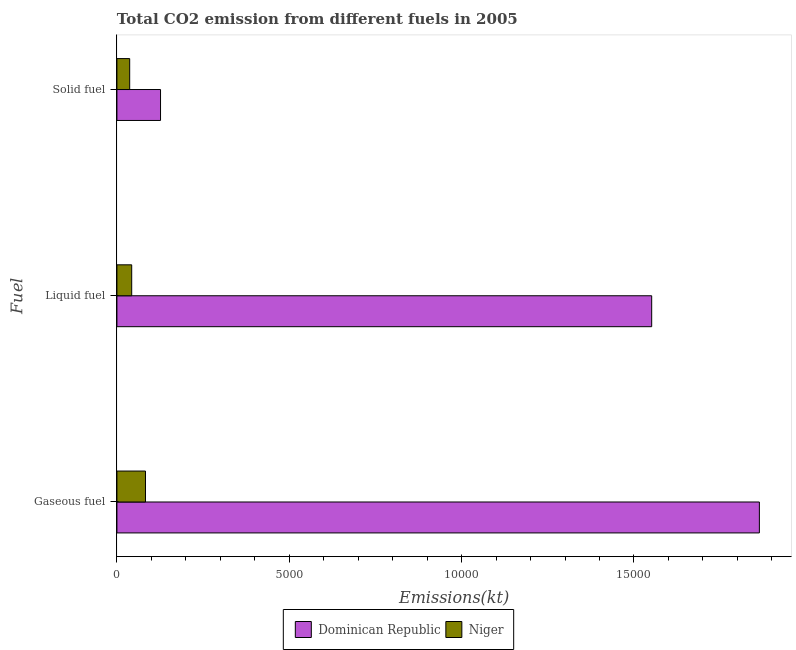How many groups of bars are there?
Make the answer very short. 3. How many bars are there on the 1st tick from the top?
Offer a terse response. 2. What is the label of the 2nd group of bars from the top?
Provide a short and direct response. Liquid fuel. What is the amount of co2 emissions from solid fuel in Dominican Republic?
Give a very brief answer. 1265.12. Across all countries, what is the maximum amount of co2 emissions from gaseous fuel?
Your answer should be compact. 1.86e+04. Across all countries, what is the minimum amount of co2 emissions from liquid fuel?
Give a very brief answer. 429.04. In which country was the amount of co2 emissions from gaseous fuel maximum?
Offer a terse response. Dominican Republic. In which country was the amount of co2 emissions from liquid fuel minimum?
Offer a very short reply. Niger. What is the total amount of co2 emissions from gaseous fuel in the graph?
Provide a short and direct response. 1.95e+04. What is the difference between the amount of co2 emissions from solid fuel in Niger and that in Dominican Republic?
Offer a terse response. -894.75. What is the difference between the amount of co2 emissions from liquid fuel in Dominican Republic and the amount of co2 emissions from solid fuel in Niger?
Your answer should be very brief. 1.51e+04. What is the average amount of co2 emissions from gaseous fuel per country?
Keep it short and to the point. 9734.05. What is the difference between the amount of co2 emissions from gaseous fuel and amount of co2 emissions from solid fuel in Niger?
Your answer should be very brief. 458.37. In how many countries, is the amount of co2 emissions from liquid fuel greater than 16000 kt?
Offer a terse response. 0. What is the ratio of the amount of co2 emissions from gaseous fuel in Niger to that in Dominican Republic?
Keep it short and to the point. 0.04. Is the difference between the amount of co2 emissions from liquid fuel in Dominican Republic and Niger greater than the difference between the amount of co2 emissions from solid fuel in Dominican Republic and Niger?
Make the answer very short. Yes. What is the difference between the highest and the second highest amount of co2 emissions from gaseous fuel?
Offer a very short reply. 1.78e+04. What is the difference between the highest and the lowest amount of co2 emissions from gaseous fuel?
Ensure brevity in your answer.  1.78e+04. In how many countries, is the amount of co2 emissions from gaseous fuel greater than the average amount of co2 emissions from gaseous fuel taken over all countries?
Your answer should be very brief. 1. What does the 2nd bar from the top in Solid fuel represents?
Offer a very short reply. Dominican Republic. What does the 1st bar from the bottom in Liquid fuel represents?
Your answer should be compact. Dominican Republic. Are all the bars in the graph horizontal?
Provide a succinct answer. Yes. Are the values on the major ticks of X-axis written in scientific E-notation?
Offer a terse response. No. Does the graph contain grids?
Provide a short and direct response. No. How many legend labels are there?
Offer a very short reply. 2. What is the title of the graph?
Make the answer very short. Total CO2 emission from different fuels in 2005. What is the label or title of the X-axis?
Keep it short and to the point. Emissions(kt). What is the label or title of the Y-axis?
Your response must be concise. Fuel. What is the Emissions(kt) of Dominican Republic in Gaseous fuel?
Give a very brief answer. 1.86e+04. What is the Emissions(kt) in Niger in Gaseous fuel?
Offer a very short reply. 828.74. What is the Emissions(kt) in Dominican Republic in Liquid fuel?
Provide a short and direct response. 1.55e+04. What is the Emissions(kt) of Niger in Liquid fuel?
Provide a short and direct response. 429.04. What is the Emissions(kt) of Dominican Republic in Solid fuel?
Your answer should be very brief. 1265.12. What is the Emissions(kt) in Niger in Solid fuel?
Keep it short and to the point. 370.37. Across all Fuel, what is the maximum Emissions(kt) of Dominican Republic?
Ensure brevity in your answer.  1.86e+04. Across all Fuel, what is the maximum Emissions(kt) in Niger?
Offer a terse response. 828.74. Across all Fuel, what is the minimum Emissions(kt) in Dominican Republic?
Your answer should be very brief. 1265.12. Across all Fuel, what is the minimum Emissions(kt) of Niger?
Offer a terse response. 370.37. What is the total Emissions(kt) in Dominican Republic in the graph?
Make the answer very short. 3.54e+04. What is the total Emissions(kt) in Niger in the graph?
Your response must be concise. 1628.15. What is the difference between the Emissions(kt) of Dominican Republic in Gaseous fuel and that in Liquid fuel?
Your answer should be very brief. 3124.28. What is the difference between the Emissions(kt) in Niger in Gaseous fuel and that in Liquid fuel?
Provide a short and direct response. 399.7. What is the difference between the Emissions(kt) of Dominican Republic in Gaseous fuel and that in Solid fuel?
Keep it short and to the point. 1.74e+04. What is the difference between the Emissions(kt) in Niger in Gaseous fuel and that in Solid fuel?
Offer a very short reply. 458.38. What is the difference between the Emissions(kt) of Dominican Republic in Liquid fuel and that in Solid fuel?
Offer a terse response. 1.42e+04. What is the difference between the Emissions(kt) of Niger in Liquid fuel and that in Solid fuel?
Offer a very short reply. 58.67. What is the difference between the Emissions(kt) in Dominican Republic in Gaseous fuel and the Emissions(kt) in Niger in Liquid fuel?
Offer a very short reply. 1.82e+04. What is the difference between the Emissions(kt) in Dominican Republic in Gaseous fuel and the Emissions(kt) in Niger in Solid fuel?
Provide a succinct answer. 1.83e+04. What is the difference between the Emissions(kt) in Dominican Republic in Liquid fuel and the Emissions(kt) in Niger in Solid fuel?
Offer a very short reply. 1.51e+04. What is the average Emissions(kt) of Dominican Republic per Fuel?
Your answer should be very brief. 1.18e+04. What is the average Emissions(kt) in Niger per Fuel?
Your answer should be compact. 542.72. What is the difference between the Emissions(kt) of Dominican Republic and Emissions(kt) of Niger in Gaseous fuel?
Give a very brief answer. 1.78e+04. What is the difference between the Emissions(kt) in Dominican Republic and Emissions(kt) in Niger in Liquid fuel?
Ensure brevity in your answer.  1.51e+04. What is the difference between the Emissions(kt) in Dominican Republic and Emissions(kt) in Niger in Solid fuel?
Ensure brevity in your answer.  894.75. What is the ratio of the Emissions(kt) of Dominican Republic in Gaseous fuel to that in Liquid fuel?
Offer a terse response. 1.2. What is the ratio of the Emissions(kt) of Niger in Gaseous fuel to that in Liquid fuel?
Make the answer very short. 1.93. What is the ratio of the Emissions(kt) in Dominican Republic in Gaseous fuel to that in Solid fuel?
Your answer should be compact. 14.73. What is the ratio of the Emissions(kt) of Niger in Gaseous fuel to that in Solid fuel?
Provide a succinct answer. 2.24. What is the ratio of the Emissions(kt) of Dominican Republic in Liquid fuel to that in Solid fuel?
Offer a very short reply. 12.26. What is the ratio of the Emissions(kt) in Niger in Liquid fuel to that in Solid fuel?
Offer a terse response. 1.16. What is the difference between the highest and the second highest Emissions(kt) of Dominican Republic?
Ensure brevity in your answer.  3124.28. What is the difference between the highest and the second highest Emissions(kt) in Niger?
Your answer should be compact. 399.7. What is the difference between the highest and the lowest Emissions(kt) in Dominican Republic?
Ensure brevity in your answer.  1.74e+04. What is the difference between the highest and the lowest Emissions(kt) of Niger?
Ensure brevity in your answer.  458.38. 